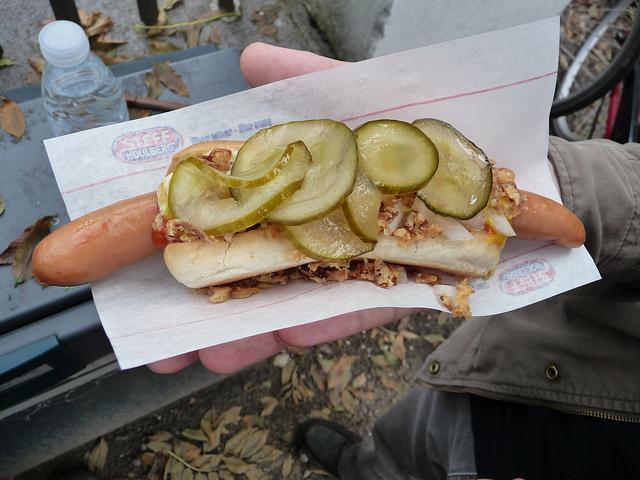How many hot dogs are visible?
Give a very brief answer. 1. How many bicycles are in the photo?
Give a very brief answer. 1. 